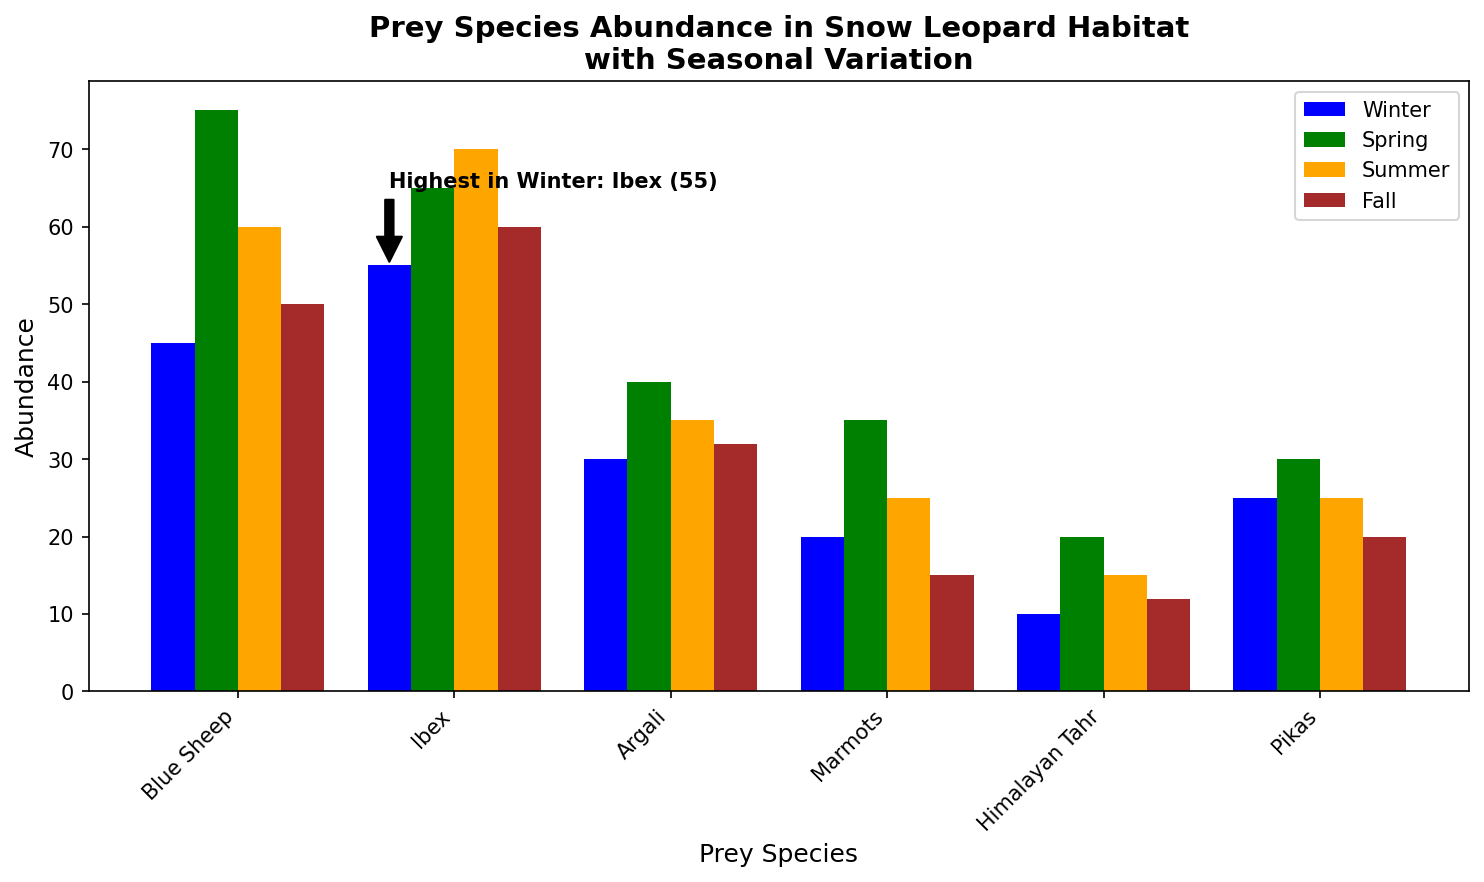Which preys have the highest abundance in winter? The highest abundance in winter is indicated by the annotation, which is for Ibex with 55.
Answer: Ibex Which season shows the highest abundance of Blue Sheep? Compare the heights of the bars for Blue Sheep across all seasons; the Spring bar is the tallest with an abundance of 75.
Answer: Spring What is the total abundance of Argali across all seasons? Sum the values for Argali: 30 (Winter) + 40 (Spring) + 35 (Summer) + 32 (Fall) = 137.
Answer: 137 Is the abundance of Marmots higher in Spring or Fall? Compare the heights of the Marmot bar in Spring (35) and Fall (15); Spring has a higher abundance.
Answer: Spring Which prey species have a higher summer abundance than winter abundance? Compare the values of summer and winter for each species: Ibex (70 > 55), Argali (35 > 30), and Himalayan Tahr (15 > 10).
Answer: Ibex, Argali, Himalayan Tahr What is the average spring abundance for all prey species? Sum all Spring values: 75 (Blue Sheep) + 65 (Ibex) + 40 (Argali) + 35 (Marmots) + 20 (Tahr) + 30 (Pikas) = 265; divide by the number of species, 6: 265/6 ≈ 44.17.
Answer: 44.17 Which species has the lowest fall abundance? Compare the heights of the bars for Fall; Himalayan Tahr has the shortest bar with an abundance of 12.
Answer: Himalayan Tahr Is the overall abundance of Pikas constant across all seasons? Compare the abundance of Pikas: Winter (25), Spring (30), Summer (25), Fall (20); they are not constant.
Answer: No Which prey species experienced the greatest drop in abundance from Spring to Fall? Calculate the difference for each species; Marmots have the largest drop: 35 (Spring) - 15 (Fall) = 20.
Answer: Marmots What is the total abundance for all prey species in Summer? Sum all Summer values: 60 (Blue Sheep) + 70 (Ibex) + 35 (Argali) + 25 (Marmots) + 15 (Tahr) + 25 (Pikas) = 230.
Answer: 230 